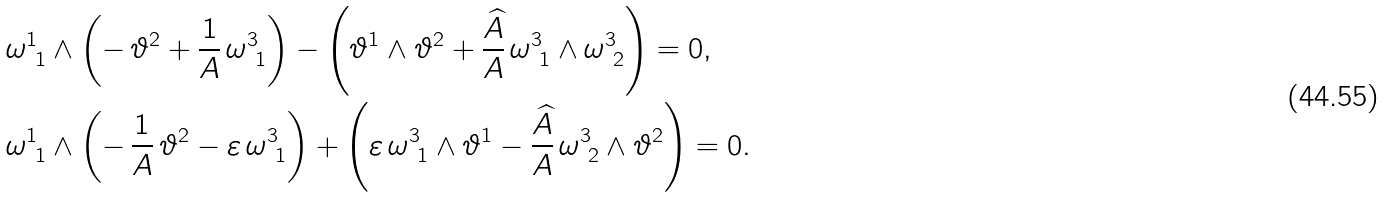<formula> <loc_0><loc_0><loc_500><loc_500>& \omega ^ { 1 } _ { \ 1 } \wedge \left ( - \, \vartheta ^ { 2 } + \frac { 1 } { A } \, \omega ^ { 3 } _ { \ 1 } \right ) - \left ( \vartheta ^ { 1 } \wedge \vartheta ^ { 2 } + \frac { \widehat { A } } { A } \, \omega ^ { 3 } _ { \ 1 } \wedge \omega ^ { 3 } _ { \ 2 } \right ) = 0 , \\ & \omega ^ { 1 } _ { \ 1 } \wedge \left ( - \, \frac { 1 } { A } \, \vartheta ^ { 2 } - \varepsilon \, \omega ^ { 3 } _ { \ 1 } \right ) + \left ( \varepsilon \, \omega ^ { 3 } _ { \ 1 } \wedge \vartheta ^ { 1 } - \frac { \widehat { A } } { A } \, \omega ^ { 3 } _ { \ 2 } \wedge \vartheta ^ { 2 } \right ) = 0 .</formula> 